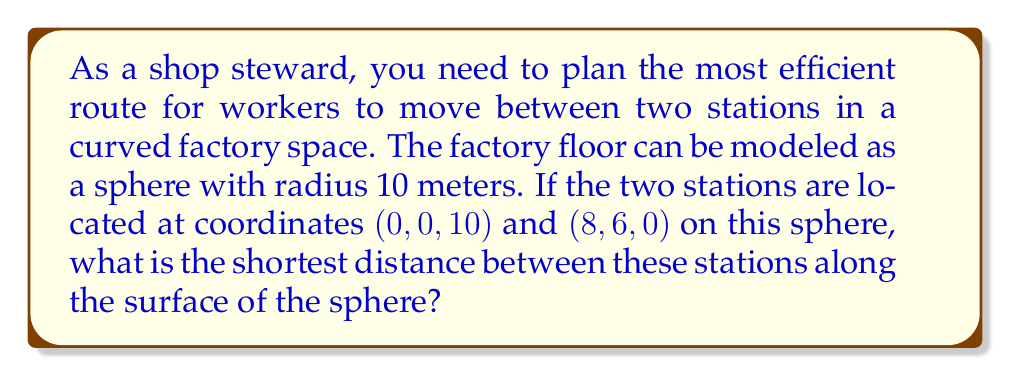Could you help me with this problem? To solve this problem, we need to use the concept of great circles in spherical geometry. The shortest path between two points on a sphere is always along a great circle. We can find this distance using the following steps:

1) First, we need to convert the given Cartesian coordinates to spherical coordinates (latitude and longitude). We can ignore the radius since it's constant.

   For point A $(0, 0, 10)$: latitude $\phi_1 = 90°$, longitude $\lambda_1 = 0°$
   For point B $(8, 6, 0)$: latitude $\phi_2 = 0°$, longitude $\lambda_2 = \arctan(6/8) = 36.87°$

2) Now we can use the spherical law of cosines to find the central angle $\theta$ between these points:

   $$\cos\theta = \sin\phi_1\sin\phi_2 + \cos\phi_1\cos\phi_2\cos(\lambda_2-\lambda_1)$$

3) Plugging in our values:

   $$\cos\theta = \sin(90°)\sin(0°) + \cos(90°)\cos(0°)\cos(36.87°-0°)$$
   $$\cos\theta = 0 \cdot 0 + 0 \cdot 1 \cdot \cos(36.87°) = 0$$

4) Therefore, $\theta = \arccos(0) = 90°$ or $\frac{\pi}{2}$ radians

5) The shortest distance $d$ along the surface is then:

   $$d = R\theta$$

   where $R$ is the radius of the sphere (10 meters) and $\theta$ is in radians.

6) So, the shortest distance is:

   $$d = 10 \cdot \frac{\pi}{2} = 5\pi \approx 15.71$$ meters
Answer: $5\pi$ meters 